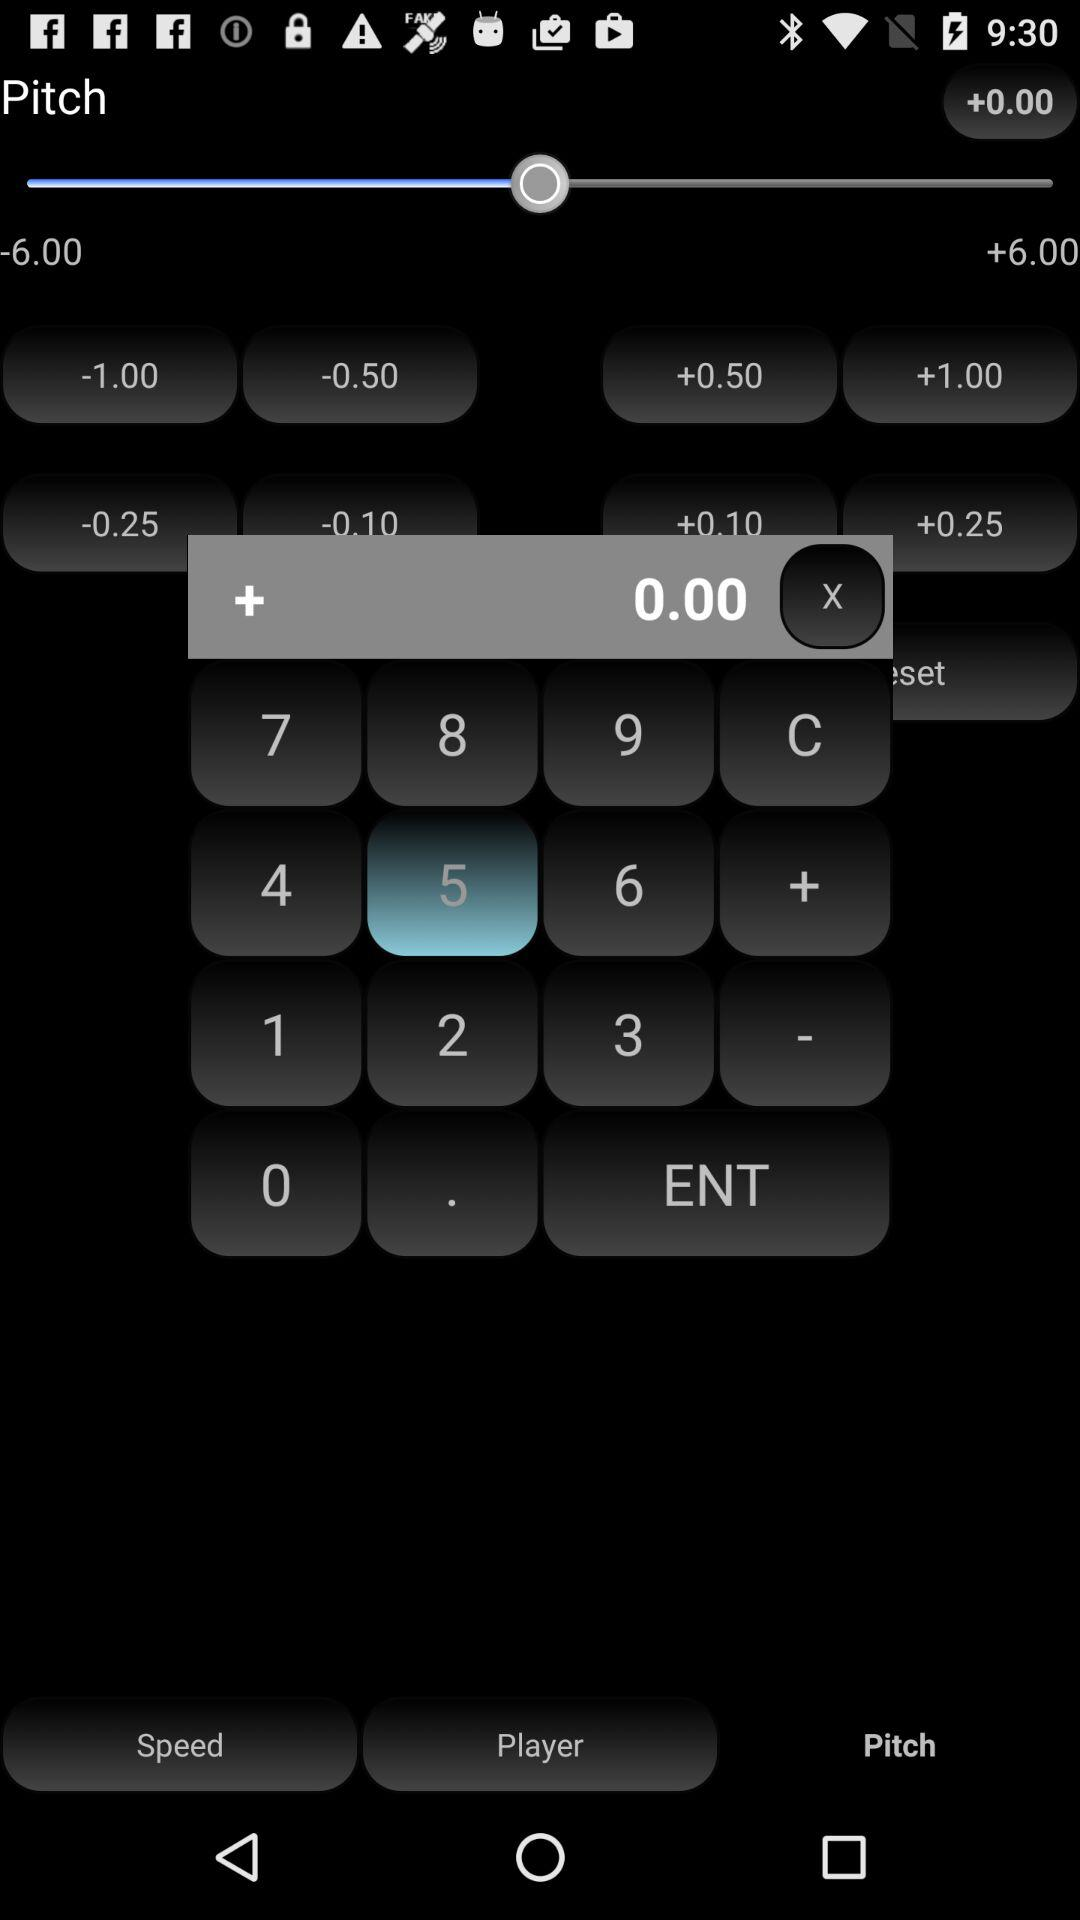What is the pitch range? The pitch ranges from -6.00 to +6.00. 